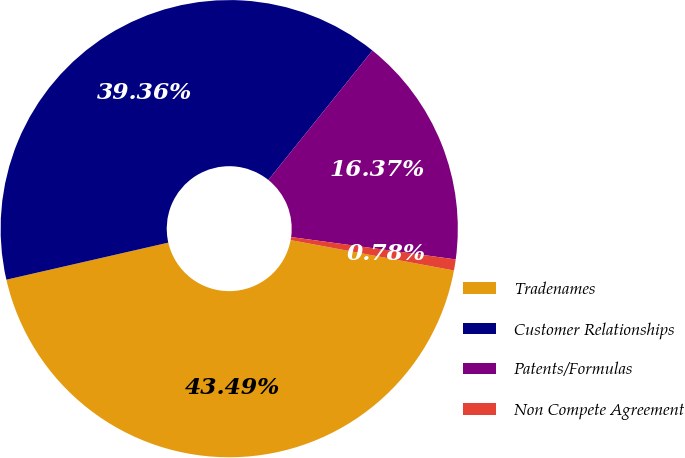Convert chart. <chart><loc_0><loc_0><loc_500><loc_500><pie_chart><fcel>Tradenames<fcel>Customer Relationships<fcel>Patents/Formulas<fcel>Non Compete Agreement<nl><fcel>43.49%<fcel>39.36%<fcel>16.37%<fcel>0.78%<nl></chart> 